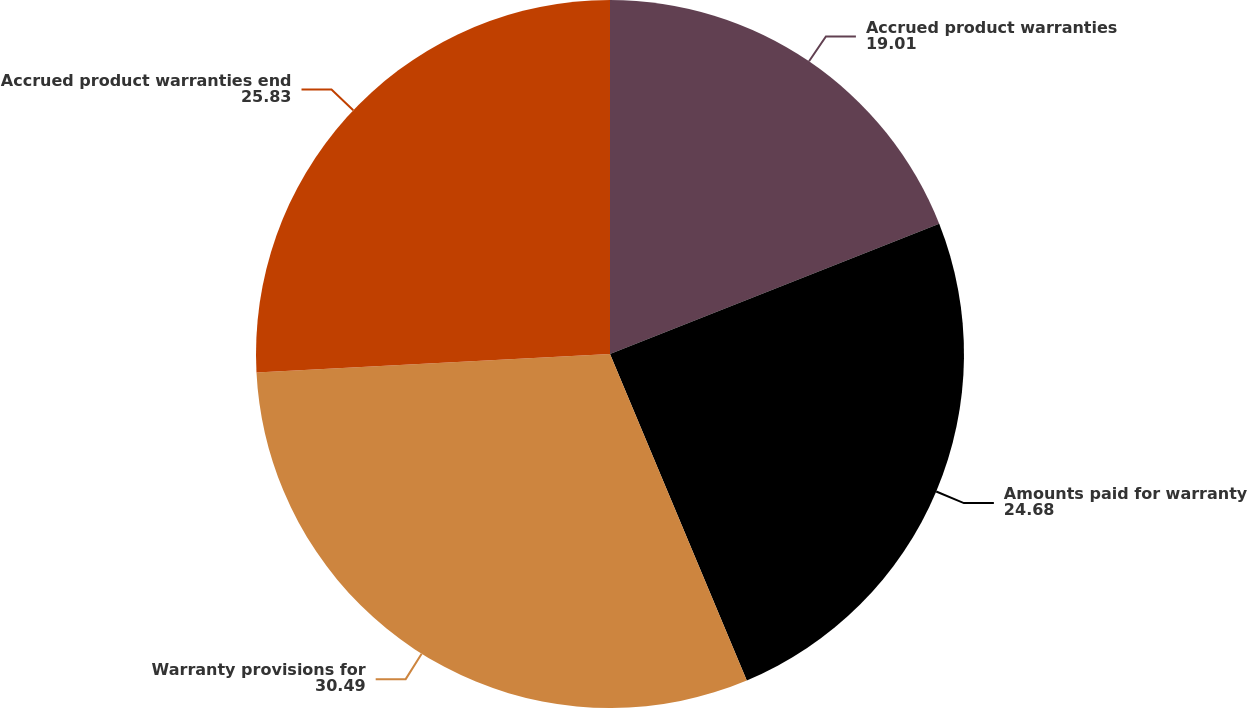Convert chart to OTSL. <chart><loc_0><loc_0><loc_500><loc_500><pie_chart><fcel>Accrued product warranties<fcel>Amounts paid for warranty<fcel>Warranty provisions for<fcel>Accrued product warranties end<nl><fcel>19.01%<fcel>24.68%<fcel>30.49%<fcel>25.83%<nl></chart> 